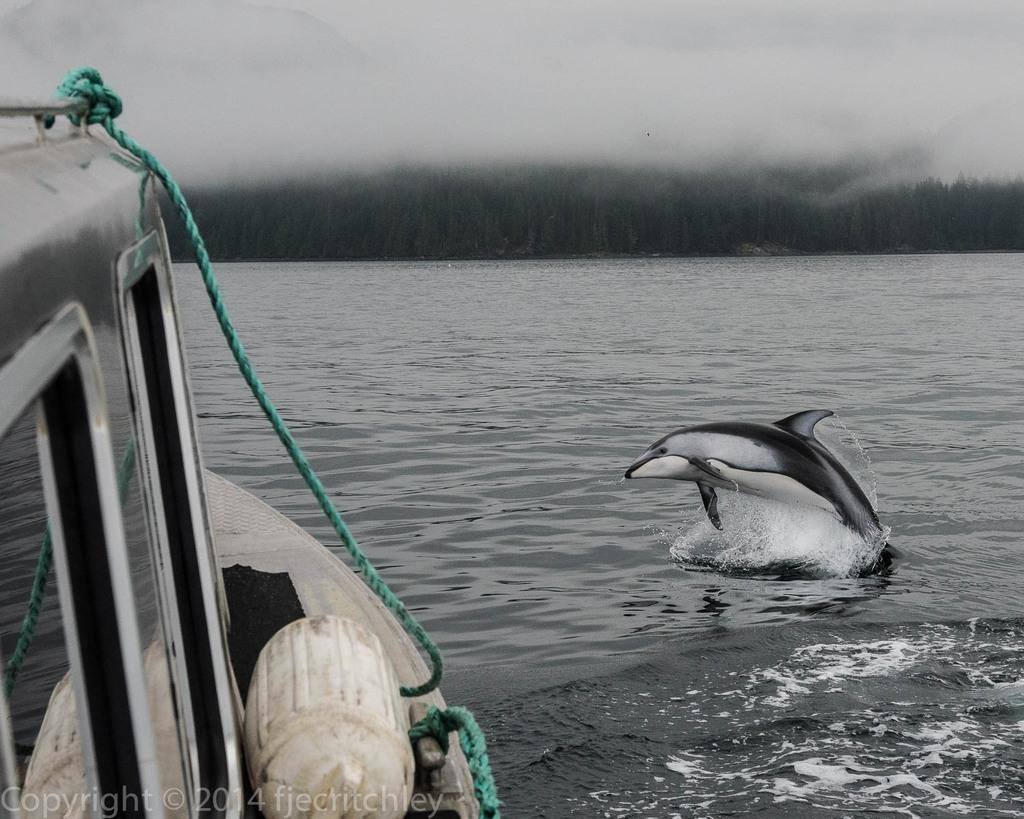What is the main subject of the image? The main subject of the image is a boat. What can be seen attached to the boat? There are green color ropes attached to the boat. What is visible in the background of the image? The background of the image includes water and a mix of white and green colors. Are there any animals visible in the image? Yes, there is a dolphin in the image. How many friends does the boat have in the image? The boat does not have friends in the image; it is an inanimate object. What type of pest can be seen causing damage to the boat in the image? There is no pest present in the image, and the boat does not appear to be damaged. 